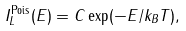<formula> <loc_0><loc_0><loc_500><loc_500>I _ { L } ^ { \text {Pois} } ( E ) = C \exp ( - E / k _ { B } T ) ,</formula> 